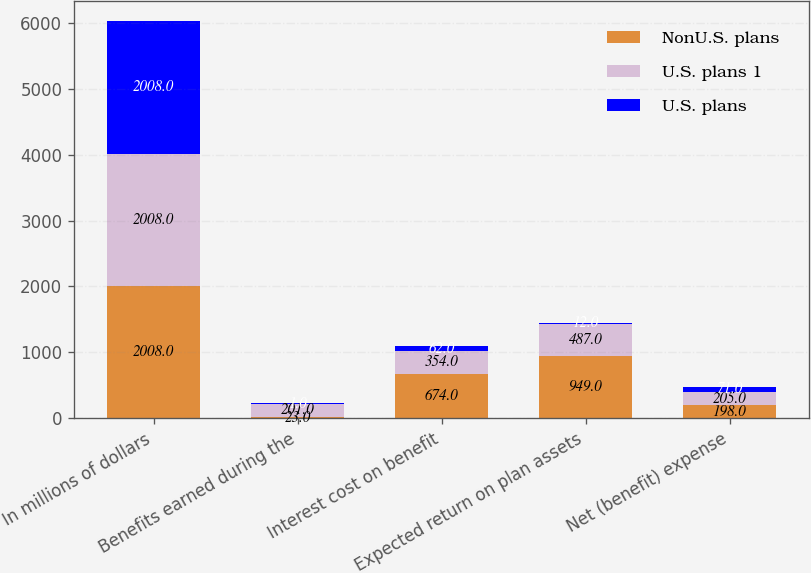Convert chart. <chart><loc_0><loc_0><loc_500><loc_500><stacked_bar_chart><ecel><fcel>In millions of dollars<fcel>Benefits earned during the<fcel>Interest cost on benefit<fcel>Expected return on plan assets<fcel>Net (benefit) expense<nl><fcel>NonU.S. plans<fcel>2008<fcel>23<fcel>674<fcel>949<fcel>198<nl><fcel>U.S. plans 1<fcel>2008<fcel>201<fcel>354<fcel>487<fcel>205<nl><fcel>U.S. plans<fcel>2008<fcel>1<fcel>62<fcel>12<fcel>71<nl></chart> 